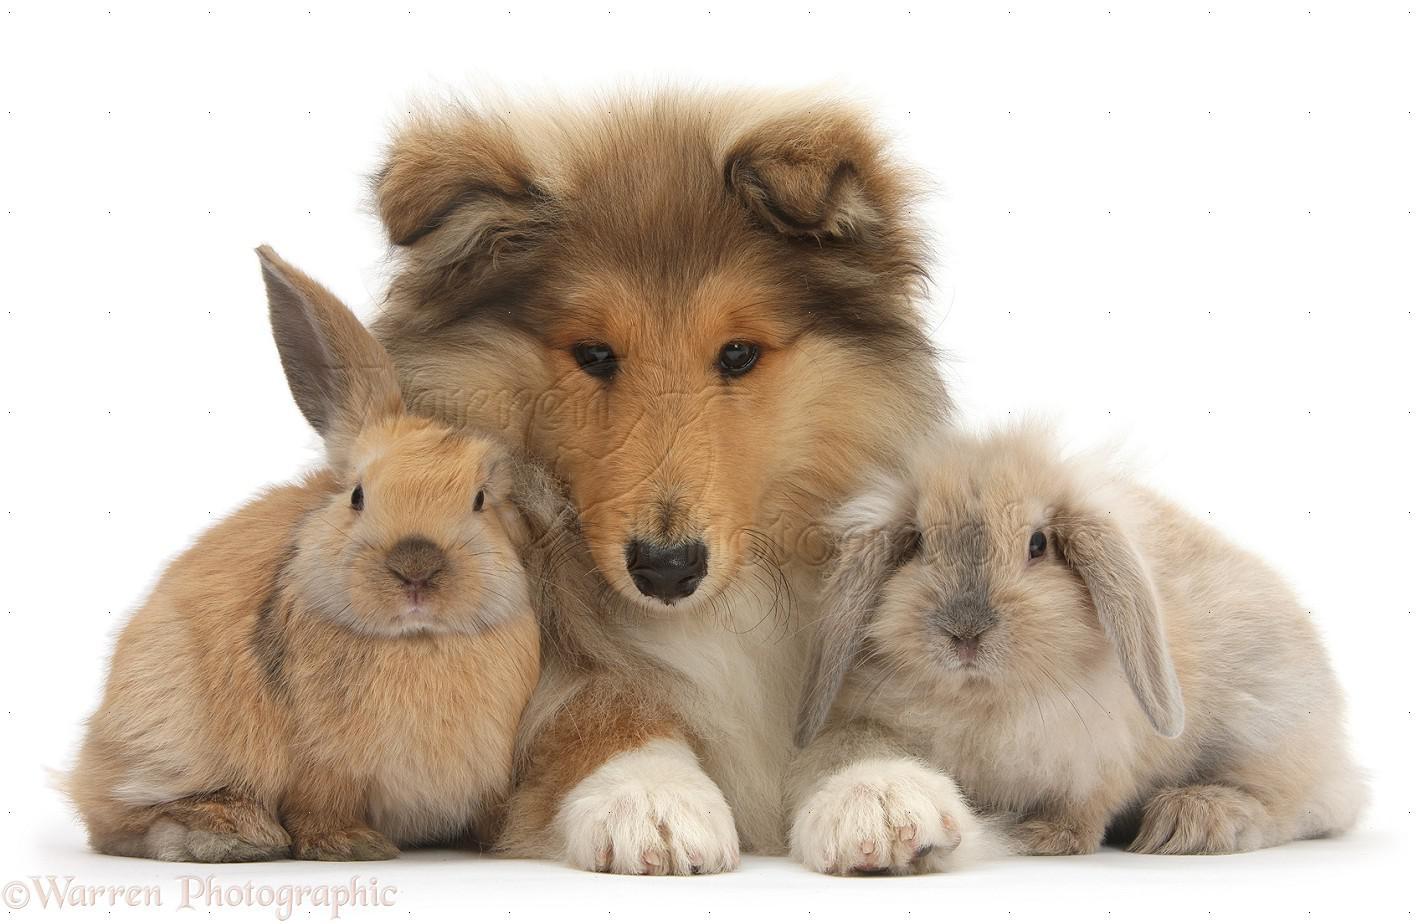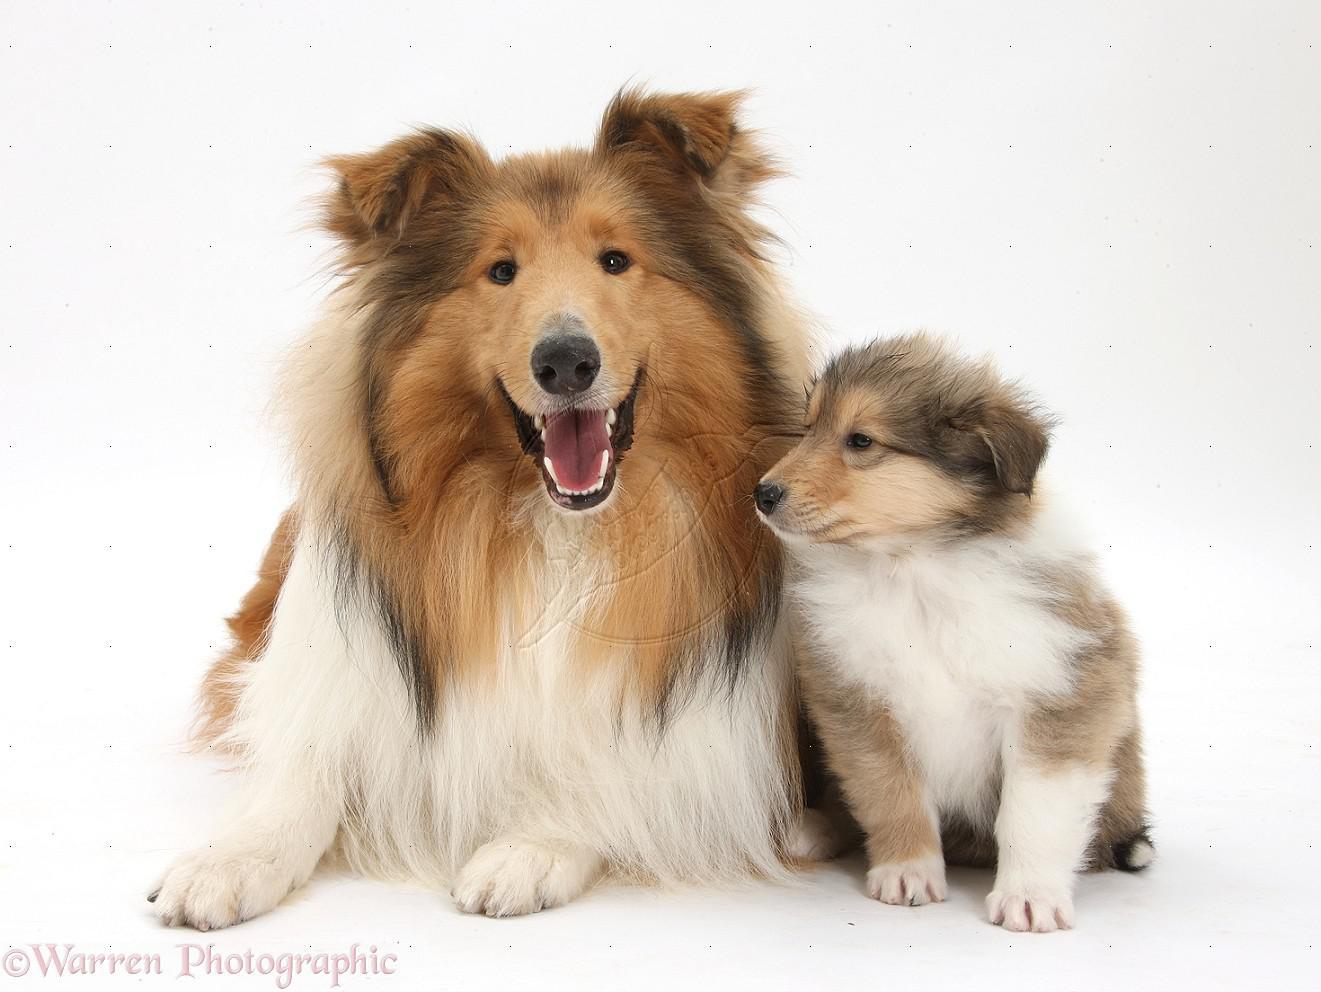The first image is the image on the left, the second image is the image on the right. For the images shown, is this caption "The right image contains exactly two dogs." true? Answer yes or no. Yes. The first image is the image on the left, the second image is the image on the right. For the images shown, is this caption "A reclining adult collie is posed alongside a collie pup sitting upright." true? Answer yes or no. Yes. 